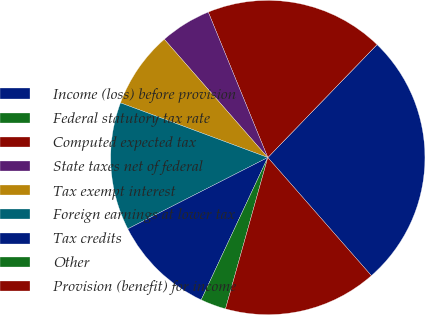Convert chart. <chart><loc_0><loc_0><loc_500><loc_500><pie_chart><fcel>Income (loss) before provision<fcel>Federal statutory tax rate<fcel>Computed expected tax<fcel>State taxes net of federal<fcel>Tax exempt interest<fcel>Foreign earnings at lower tax<fcel>Tax credits<fcel>Other<fcel>Provision (benefit) for income<nl><fcel>26.31%<fcel>0.0%<fcel>18.42%<fcel>5.26%<fcel>7.9%<fcel>13.16%<fcel>10.53%<fcel>2.63%<fcel>15.79%<nl></chart> 